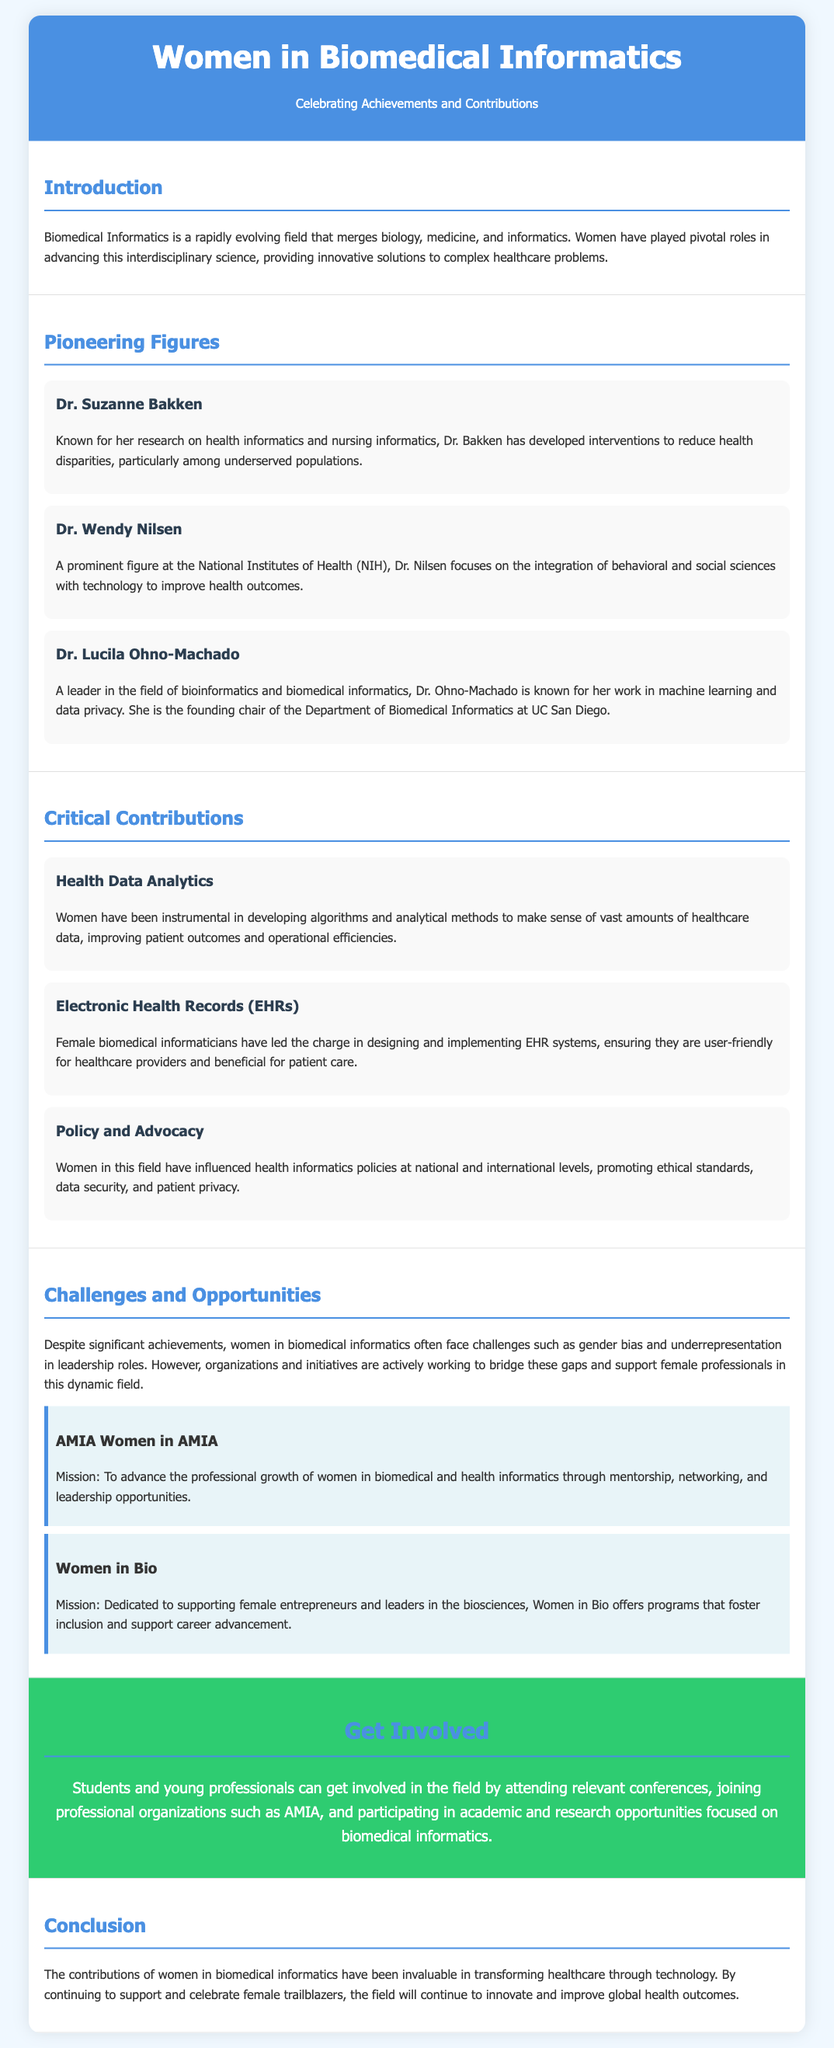What is the title of the flyer? The title is presented prominently at the top of the document.
Answer: Women in Biomedical Informatics Who is the founding chair of the Department of Biomedical Informatics at UC San Diego? This information is found under the section on pioneering figures.
Answer: Dr. Lucila Ohno-Machado What organization is dedicated to supporting female entrepreneurs in biosciences? This is mentioned in the section on organizations.
Answer: Women in Bio What major challenge do women in biomedical informatics face according to the document? This challenge is highlighted in the section on challenges and opportunities.
Answer: Gender bias What area do women significantly contribute to with regards to healthcare data? This is described in the section on critical contributions.
Answer: Health Data Analytics 